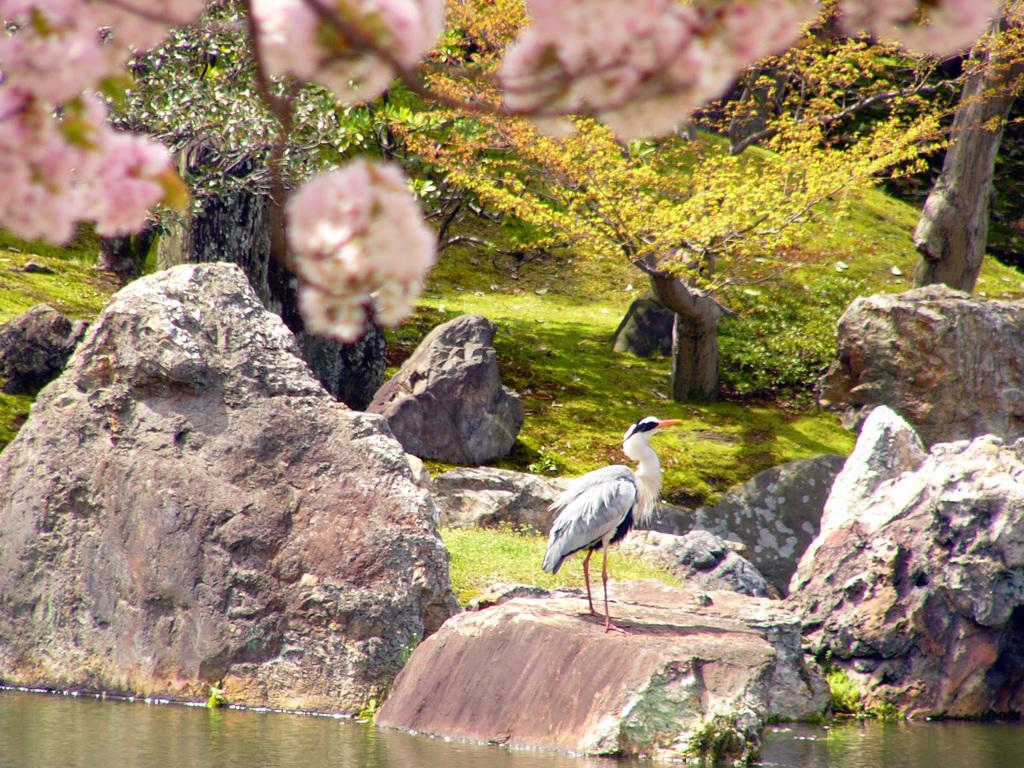What is located on the rock in the foreground of the image? There is a crane on a rock in the foreground of the image. What type of natural environment is depicted in the image? There is water, plants, trees, and grass visible in the image. Can you describe the water in the image? The water is visible in the image, but its specific characteristics are not mentioned in the facts. What type of cream is being applied to the stocking in the image? There is no cream or stocking present in the image; it features a crane on a rock in a natural environment. 